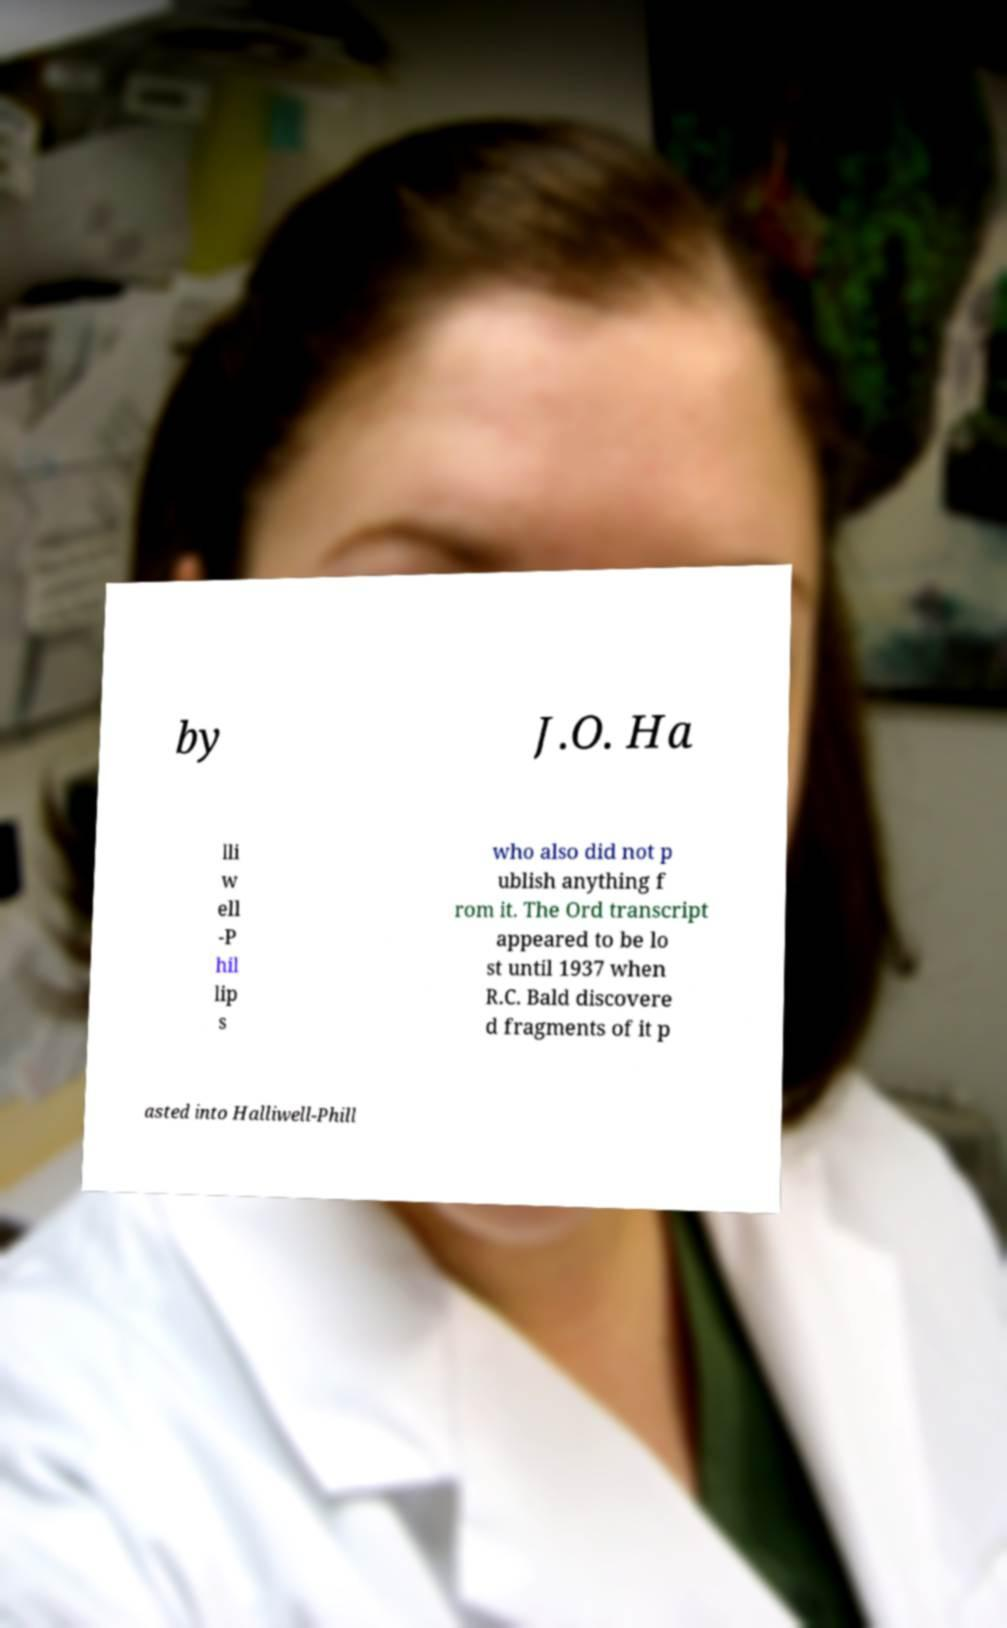Could you assist in decoding the text presented in this image and type it out clearly? by J.O. Ha lli w ell -P hil lip s who also did not p ublish anything f rom it. The Ord transcript appeared to be lo st until 1937 when R.C. Bald discovere d fragments of it p asted into Halliwell-Phill 